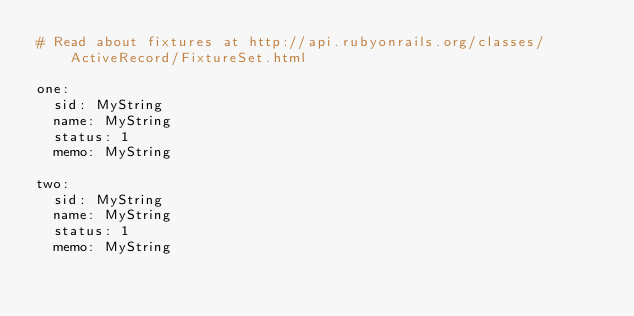<code> <loc_0><loc_0><loc_500><loc_500><_YAML_># Read about fixtures at http://api.rubyonrails.org/classes/ActiveRecord/FixtureSet.html

one:
  sid: MyString
  name: MyString
  status: 1
  memo: MyString

two:
  sid: MyString
  name: MyString
  status: 1
  memo: MyString
</code> 